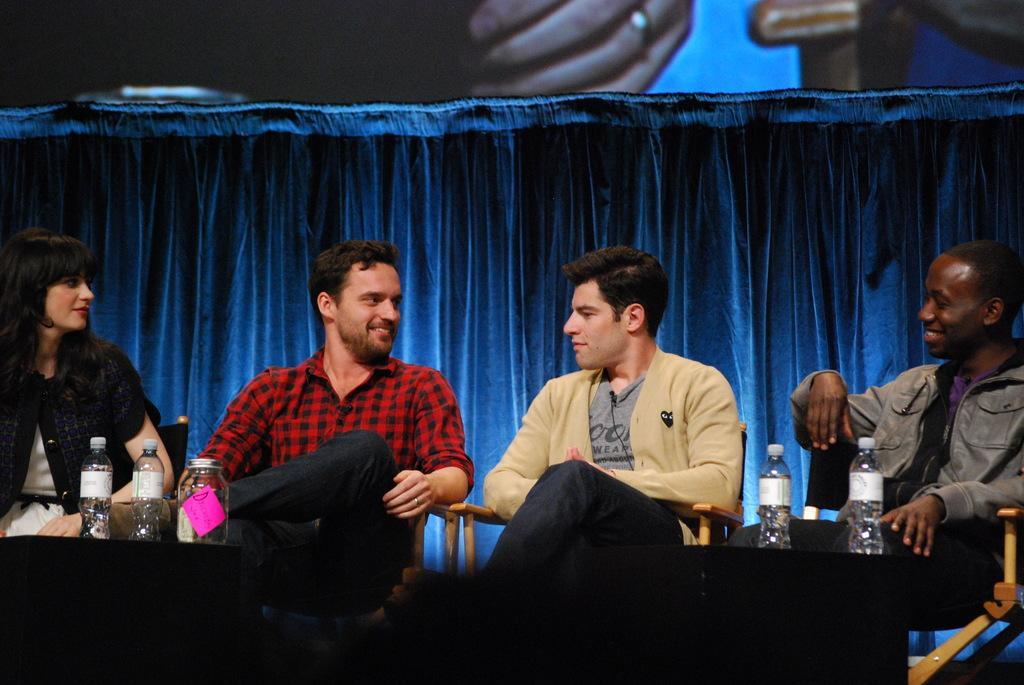Can you describe this image briefly? In this picture we can see there are four people sitting on chairs and in front of the people there are tables and on the tables there are bottles and a jar. Behind the people there is a curtain. 